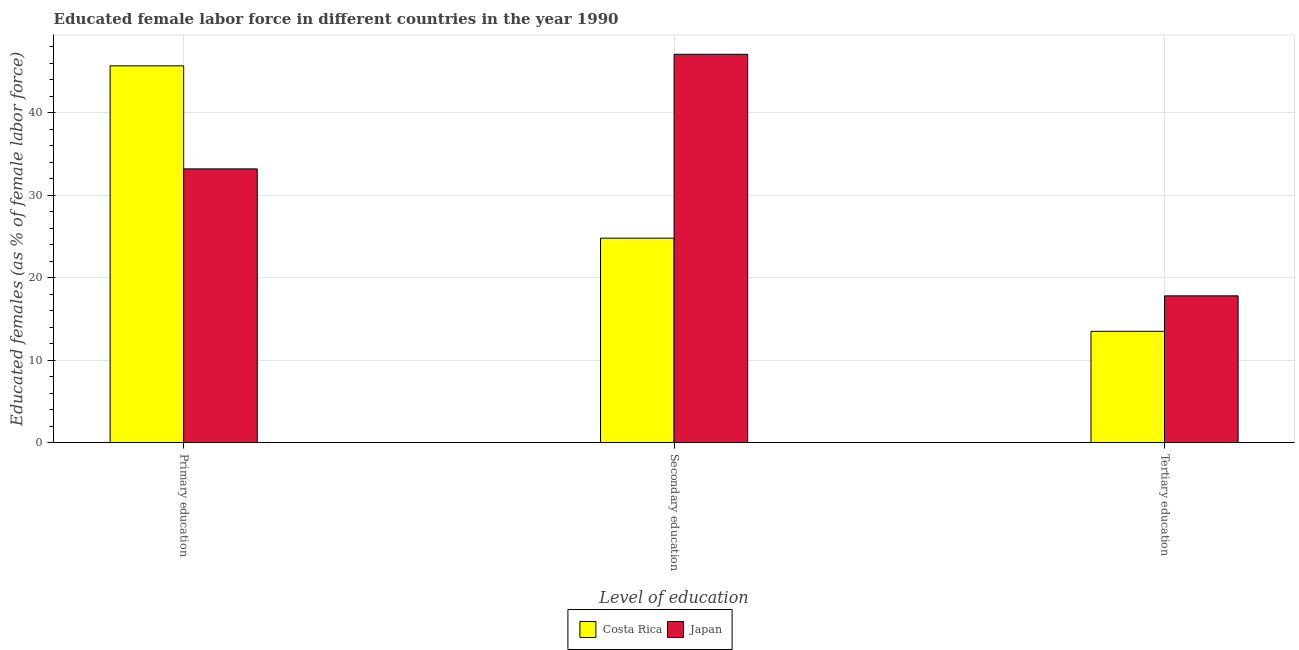How many different coloured bars are there?
Ensure brevity in your answer.  2. How many groups of bars are there?
Your answer should be compact. 3. How many bars are there on the 1st tick from the right?
Ensure brevity in your answer.  2. What is the label of the 2nd group of bars from the left?
Ensure brevity in your answer.  Secondary education. What is the percentage of female labor force who received tertiary education in Costa Rica?
Give a very brief answer. 13.5. Across all countries, what is the maximum percentage of female labor force who received secondary education?
Provide a short and direct response. 47.1. Across all countries, what is the minimum percentage of female labor force who received primary education?
Ensure brevity in your answer.  33.2. In which country was the percentage of female labor force who received primary education maximum?
Provide a short and direct response. Costa Rica. What is the total percentage of female labor force who received secondary education in the graph?
Ensure brevity in your answer.  71.9. What is the difference between the percentage of female labor force who received tertiary education in Costa Rica and that in Japan?
Your answer should be very brief. -4.3. What is the difference between the percentage of female labor force who received tertiary education in Japan and the percentage of female labor force who received primary education in Costa Rica?
Offer a very short reply. -27.9. What is the average percentage of female labor force who received secondary education per country?
Make the answer very short. 35.95. What is the difference between the percentage of female labor force who received primary education and percentage of female labor force who received secondary education in Costa Rica?
Your answer should be very brief. 20.9. What is the ratio of the percentage of female labor force who received primary education in Japan to that in Costa Rica?
Keep it short and to the point. 0.73. What is the difference between the highest and the second highest percentage of female labor force who received secondary education?
Ensure brevity in your answer.  22.3. What is the difference between the highest and the lowest percentage of female labor force who received tertiary education?
Offer a very short reply. 4.3. Is the sum of the percentage of female labor force who received primary education in Costa Rica and Japan greater than the maximum percentage of female labor force who received secondary education across all countries?
Make the answer very short. Yes. What does the 2nd bar from the right in Tertiary education represents?
Offer a terse response. Costa Rica. Is it the case that in every country, the sum of the percentage of female labor force who received primary education and percentage of female labor force who received secondary education is greater than the percentage of female labor force who received tertiary education?
Offer a terse response. Yes. How many bars are there?
Your answer should be compact. 6. How many countries are there in the graph?
Provide a succinct answer. 2. Does the graph contain any zero values?
Your answer should be very brief. No. Does the graph contain grids?
Your answer should be very brief. Yes. Where does the legend appear in the graph?
Provide a succinct answer. Bottom center. How many legend labels are there?
Keep it short and to the point. 2. What is the title of the graph?
Provide a short and direct response. Educated female labor force in different countries in the year 1990. What is the label or title of the X-axis?
Give a very brief answer. Level of education. What is the label or title of the Y-axis?
Keep it short and to the point. Educated females (as % of female labor force). What is the Educated females (as % of female labor force) in Costa Rica in Primary education?
Provide a succinct answer. 45.7. What is the Educated females (as % of female labor force) of Japan in Primary education?
Provide a short and direct response. 33.2. What is the Educated females (as % of female labor force) in Costa Rica in Secondary education?
Ensure brevity in your answer.  24.8. What is the Educated females (as % of female labor force) of Japan in Secondary education?
Give a very brief answer. 47.1. What is the Educated females (as % of female labor force) of Costa Rica in Tertiary education?
Keep it short and to the point. 13.5. What is the Educated females (as % of female labor force) of Japan in Tertiary education?
Your answer should be very brief. 17.8. Across all Level of education, what is the maximum Educated females (as % of female labor force) of Costa Rica?
Offer a terse response. 45.7. Across all Level of education, what is the maximum Educated females (as % of female labor force) of Japan?
Provide a short and direct response. 47.1. Across all Level of education, what is the minimum Educated females (as % of female labor force) of Japan?
Your answer should be compact. 17.8. What is the total Educated females (as % of female labor force) in Costa Rica in the graph?
Make the answer very short. 84. What is the total Educated females (as % of female labor force) in Japan in the graph?
Make the answer very short. 98.1. What is the difference between the Educated females (as % of female labor force) of Costa Rica in Primary education and that in Secondary education?
Your answer should be very brief. 20.9. What is the difference between the Educated females (as % of female labor force) in Japan in Primary education and that in Secondary education?
Your answer should be very brief. -13.9. What is the difference between the Educated females (as % of female labor force) in Costa Rica in Primary education and that in Tertiary education?
Keep it short and to the point. 32.2. What is the difference between the Educated females (as % of female labor force) in Japan in Secondary education and that in Tertiary education?
Provide a short and direct response. 29.3. What is the difference between the Educated females (as % of female labor force) in Costa Rica in Primary education and the Educated females (as % of female labor force) in Japan in Secondary education?
Offer a terse response. -1.4. What is the difference between the Educated females (as % of female labor force) in Costa Rica in Primary education and the Educated females (as % of female labor force) in Japan in Tertiary education?
Give a very brief answer. 27.9. What is the difference between the Educated females (as % of female labor force) of Costa Rica in Secondary education and the Educated females (as % of female labor force) of Japan in Tertiary education?
Your answer should be very brief. 7. What is the average Educated females (as % of female labor force) of Japan per Level of education?
Make the answer very short. 32.7. What is the difference between the Educated females (as % of female labor force) of Costa Rica and Educated females (as % of female labor force) of Japan in Primary education?
Your answer should be compact. 12.5. What is the difference between the Educated females (as % of female labor force) of Costa Rica and Educated females (as % of female labor force) of Japan in Secondary education?
Provide a succinct answer. -22.3. What is the difference between the Educated females (as % of female labor force) in Costa Rica and Educated females (as % of female labor force) in Japan in Tertiary education?
Offer a terse response. -4.3. What is the ratio of the Educated females (as % of female labor force) in Costa Rica in Primary education to that in Secondary education?
Provide a short and direct response. 1.84. What is the ratio of the Educated females (as % of female labor force) of Japan in Primary education to that in Secondary education?
Give a very brief answer. 0.7. What is the ratio of the Educated females (as % of female labor force) of Costa Rica in Primary education to that in Tertiary education?
Your answer should be compact. 3.39. What is the ratio of the Educated females (as % of female labor force) of Japan in Primary education to that in Tertiary education?
Make the answer very short. 1.87. What is the ratio of the Educated females (as % of female labor force) in Costa Rica in Secondary education to that in Tertiary education?
Offer a very short reply. 1.84. What is the ratio of the Educated females (as % of female labor force) of Japan in Secondary education to that in Tertiary education?
Make the answer very short. 2.65. What is the difference between the highest and the second highest Educated females (as % of female labor force) of Costa Rica?
Your answer should be very brief. 20.9. What is the difference between the highest and the lowest Educated females (as % of female labor force) in Costa Rica?
Ensure brevity in your answer.  32.2. What is the difference between the highest and the lowest Educated females (as % of female labor force) in Japan?
Ensure brevity in your answer.  29.3. 